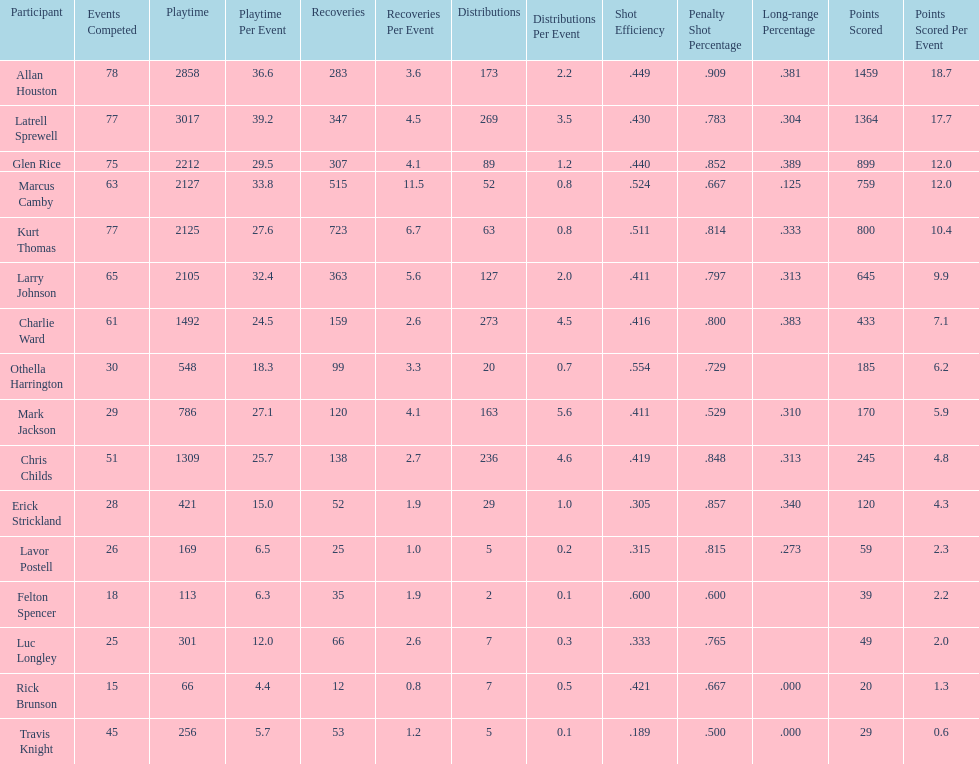How many more games did allan houston play than mark jackson? 49. 